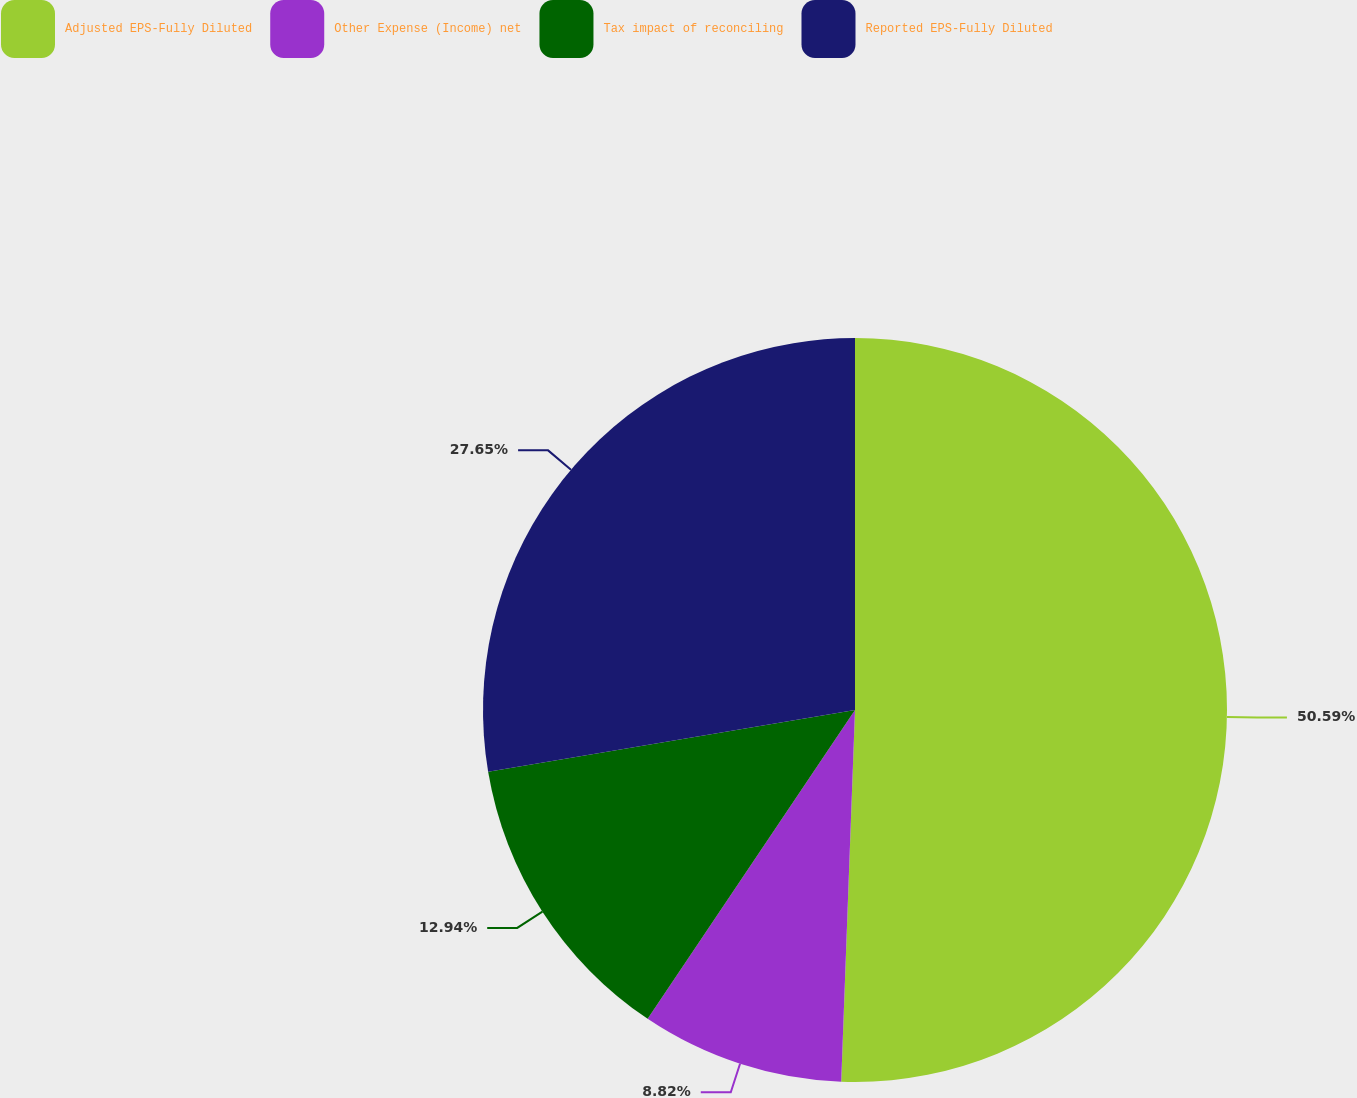Convert chart to OTSL. <chart><loc_0><loc_0><loc_500><loc_500><pie_chart><fcel>Adjusted EPS-Fully Diluted<fcel>Other Expense (Income) net<fcel>Tax impact of reconciling<fcel>Reported EPS-Fully Diluted<nl><fcel>50.59%<fcel>8.82%<fcel>12.94%<fcel>27.65%<nl></chart> 